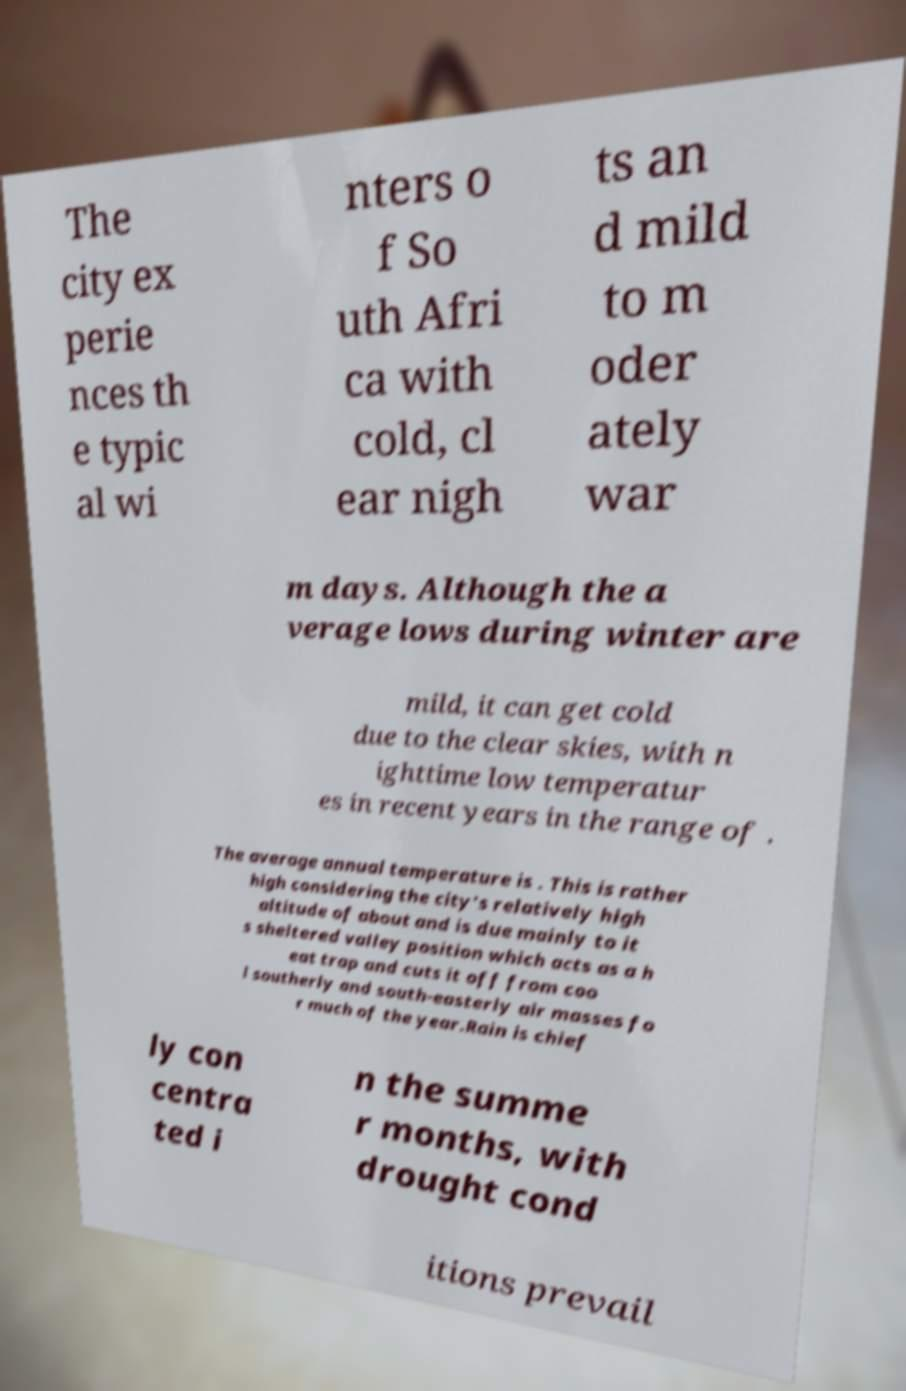Can you read and provide the text displayed in the image?This photo seems to have some interesting text. Can you extract and type it out for me? The city ex perie nces th e typic al wi nters o f So uth Afri ca with cold, cl ear nigh ts an d mild to m oder ately war m days. Although the a verage lows during winter are mild, it can get cold due to the clear skies, with n ighttime low temperatur es in recent years in the range of . The average annual temperature is . This is rather high considering the city's relatively high altitude of about and is due mainly to it s sheltered valley position which acts as a h eat trap and cuts it off from coo l southerly and south-easterly air masses fo r much of the year.Rain is chief ly con centra ted i n the summe r months, with drought cond itions prevail 